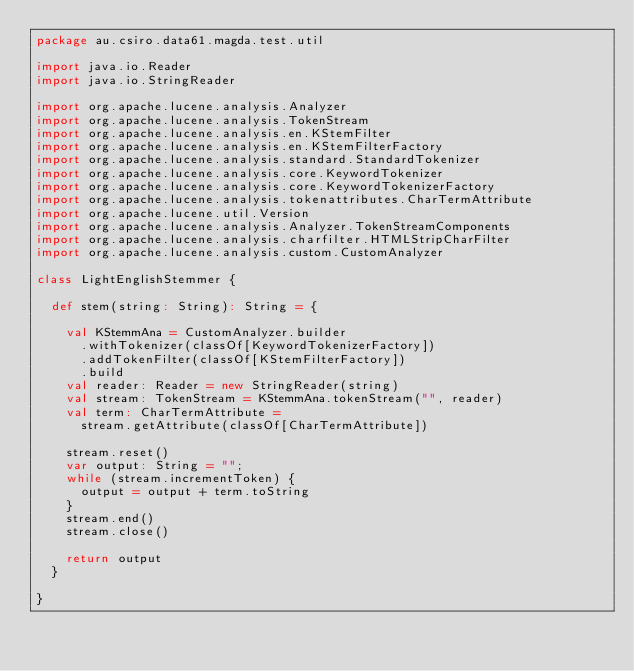<code> <loc_0><loc_0><loc_500><loc_500><_Scala_>package au.csiro.data61.magda.test.util

import java.io.Reader
import java.io.StringReader

import org.apache.lucene.analysis.Analyzer
import org.apache.lucene.analysis.TokenStream
import org.apache.lucene.analysis.en.KStemFilter
import org.apache.lucene.analysis.en.KStemFilterFactory
import org.apache.lucene.analysis.standard.StandardTokenizer
import org.apache.lucene.analysis.core.KeywordTokenizer
import org.apache.lucene.analysis.core.KeywordTokenizerFactory
import org.apache.lucene.analysis.tokenattributes.CharTermAttribute
import org.apache.lucene.util.Version
import org.apache.lucene.analysis.Analyzer.TokenStreamComponents
import org.apache.lucene.analysis.charfilter.HTMLStripCharFilter
import org.apache.lucene.analysis.custom.CustomAnalyzer

class LightEnglishStemmer {

  def stem(string: String): String = {

    val KStemmAna = CustomAnalyzer.builder
      .withTokenizer(classOf[KeywordTokenizerFactory])
      .addTokenFilter(classOf[KStemFilterFactory])
      .build
    val reader: Reader = new StringReader(string)
    val stream: TokenStream = KStemmAna.tokenStream("", reader)
    val term: CharTermAttribute =
      stream.getAttribute(classOf[CharTermAttribute])

    stream.reset()
    var output: String = "";
    while (stream.incrementToken) {
      output = output + term.toString
    }
    stream.end()
    stream.close()

    return output
  }

}
</code> 